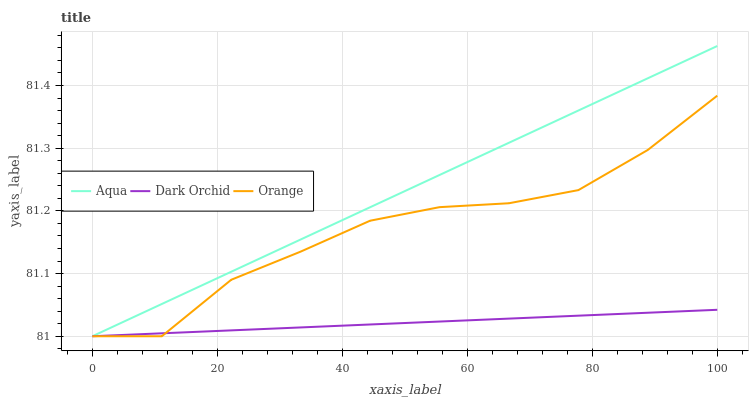Does Dark Orchid have the minimum area under the curve?
Answer yes or no. Yes. Does Aqua have the maximum area under the curve?
Answer yes or no. Yes. Does Aqua have the minimum area under the curve?
Answer yes or no. No. Does Dark Orchid have the maximum area under the curve?
Answer yes or no. No. Is Aqua the smoothest?
Answer yes or no. Yes. Is Orange the roughest?
Answer yes or no. Yes. Is Dark Orchid the smoothest?
Answer yes or no. No. Is Dark Orchid the roughest?
Answer yes or no. No. Does Orange have the lowest value?
Answer yes or no. Yes. Does Aqua have the highest value?
Answer yes or no. Yes. Does Dark Orchid have the highest value?
Answer yes or no. No. Does Aqua intersect Orange?
Answer yes or no. Yes. Is Aqua less than Orange?
Answer yes or no. No. Is Aqua greater than Orange?
Answer yes or no. No. 